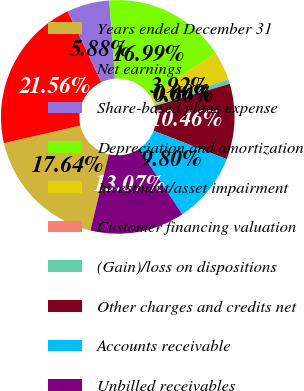Convert chart. <chart><loc_0><loc_0><loc_500><loc_500><pie_chart><fcel>Years ended December 31<fcel>Net earnings<fcel>Share-based plans expense<fcel>Depreciation and amortization<fcel>Investment/asset impairment<fcel>Customer financing valuation<fcel>(Gain)/loss on dispositions<fcel>Other charges and credits net<fcel>Accounts receivable<fcel>Unbilled receivables<nl><fcel>17.64%<fcel>21.56%<fcel>5.88%<fcel>16.99%<fcel>3.92%<fcel>0.0%<fcel>0.66%<fcel>10.46%<fcel>9.8%<fcel>13.07%<nl></chart> 